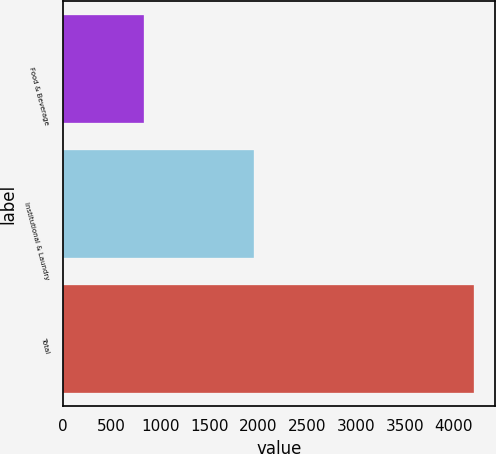<chart> <loc_0><loc_0><loc_500><loc_500><bar_chart><fcel>Food & Beverage<fcel>Institutional & Laundry<fcel>Total<nl><fcel>833.7<fcel>1958.6<fcel>4209.6<nl></chart> 